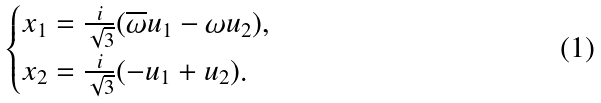Convert formula to latex. <formula><loc_0><loc_0><loc_500><loc_500>\begin{cases} x _ { 1 } = \frac { i } { \sqrt { 3 } } ( \overline { \omega } u _ { 1 } - \omega u _ { 2 } ) , \\ x _ { 2 } = \frac { i } { \sqrt { 3 } } ( - u _ { 1 } + u _ { 2 } ) . \end{cases}</formula> 